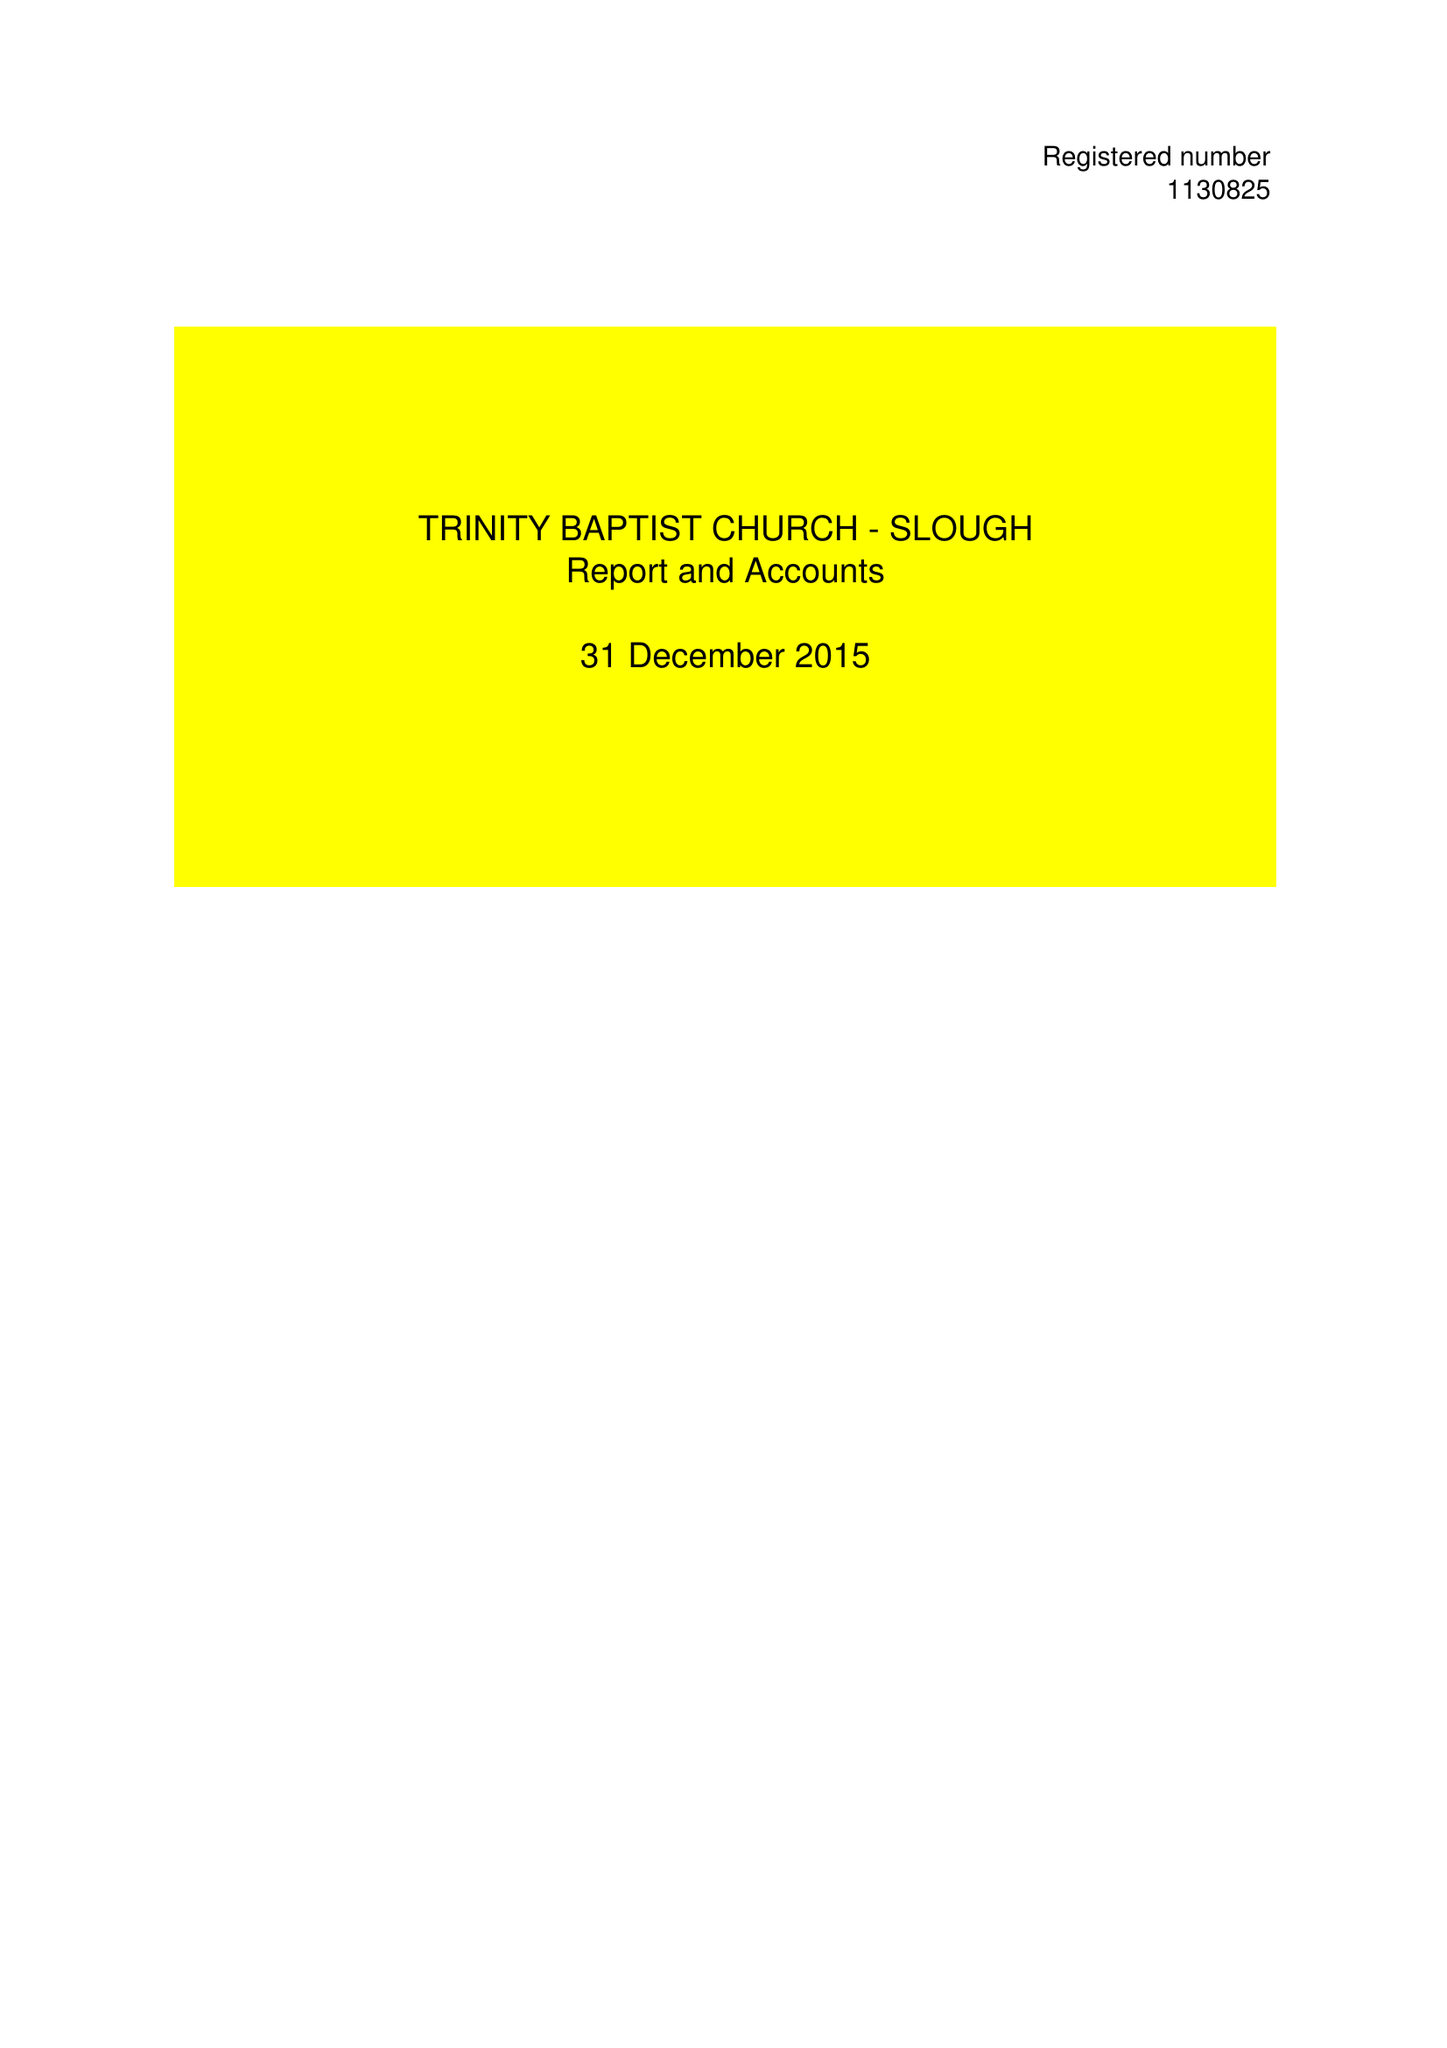What is the value for the address__postcode?
Answer the question using a single word or phrase. CR4 1XH 